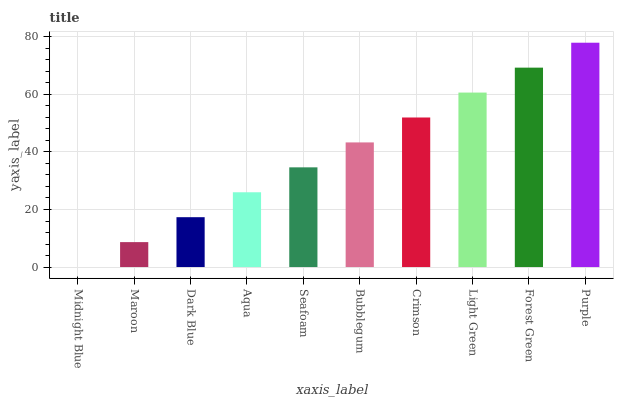Is Midnight Blue the minimum?
Answer yes or no. Yes. Is Purple the maximum?
Answer yes or no. Yes. Is Maroon the minimum?
Answer yes or no. No. Is Maroon the maximum?
Answer yes or no. No. Is Maroon greater than Midnight Blue?
Answer yes or no. Yes. Is Midnight Blue less than Maroon?
Answer yes or no. Yes. Is Midnight Blue greater than Maroon?
Answer yes or no. No. Is Maroon less than Midnight Blue?
Answer yes or no. No. Is Bubblegum the high median?
Answer yes or no. Yes. Is Seafoam the low median?
Answer yes or no. Yes. Is Aqua the high median?
Answer yes or no. No. Is Light Green the low median?
Answer yes or no. No. 